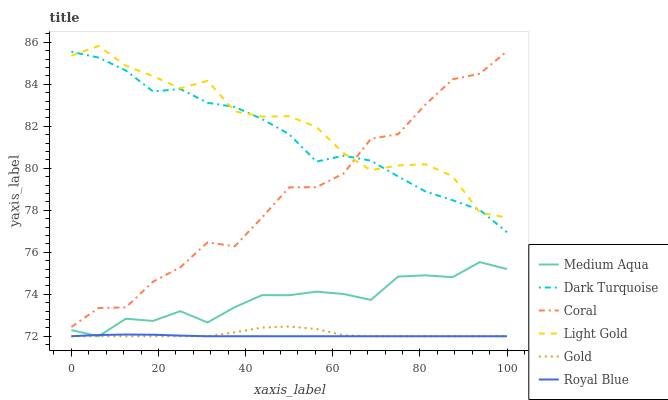Does Royal Blue have the minimum area under the curve?
Answer yes or no. Yes. Does Light Gold have the maximum area under the curve?
Answer yes or no. Yes. Does Dark Turquoise have the minimum area under the curve?
Answer yes or no. No. Does Dark Turquoise have the maximum area under the curve?
Answer yes or no. No. Is Royal Blue the smoothest?
Answer yes or no. Yes. Is Coral the roughest?
Answer yes or no. Yes. Is Dark Turquoise the smoothest?
Answer yes or no. No. Is Dark Turquoise the roughest?
Answer yes or no. No. Does Dark Turquoise have the lowest value?
Answer yes or no. No. Does Light Gold have the highest value?
Answer yes or no. Yes. Does Dark Turquoise have the highest value?
Answer yes or no. No. Is Gold less than Light Gold?
Answer yes or no. Yes. Is Light Gold greater than Royal Blue?
Answer yes or no. Yes. Does Light Gold intersect Dark Turquoise?
Answer yes or no. Yes. Is Light Gold less than Dark Turquoise?
Answer yes or no. No. Is Light Gold greater than Dark Turquoise?
Answer yes or no. No. Does Gold intersect Light Gold?
Answer yes or no. No. 